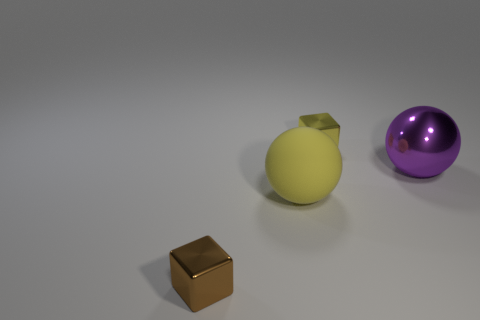Add 2 metal spheres. How many objects exist? 6 Add 4 small objects. How many small objects are left? 6 Add 4 small blue rubber objects. How many small blue rubber objects exist? 4 Subtract 1 yellow cubes. How many objects are left? 3 Subtract all metal things. Subtract all tiny gray blocks. How many objects are left? 1 